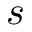Convert formula to latex. <formula><loc_0><loc_0><loc_500><loc_500>s</formula> 